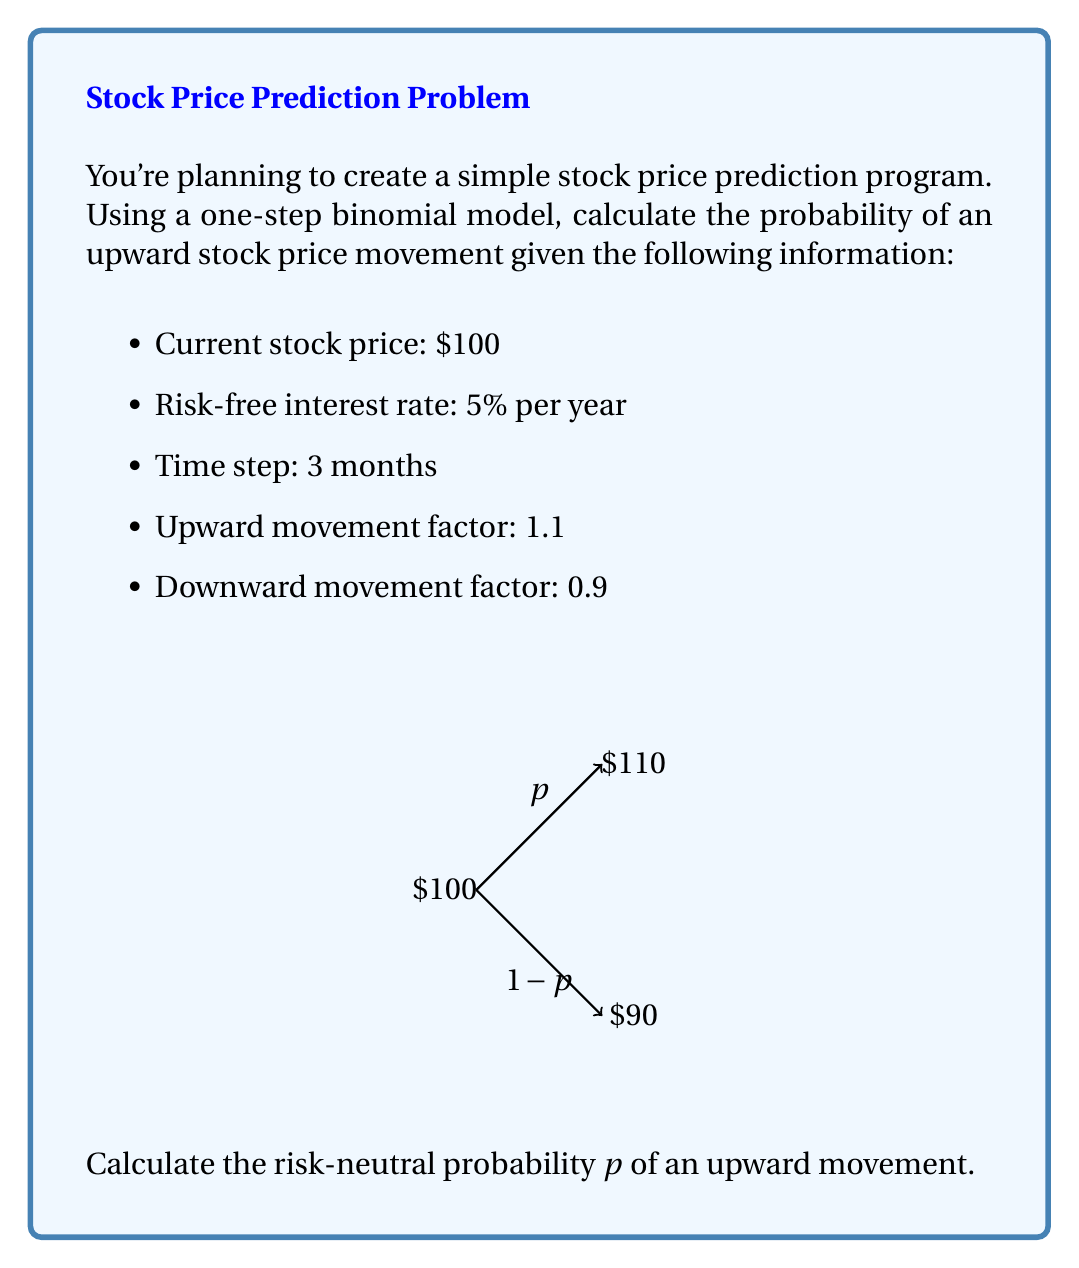Can you solve this math problem? To solve this problem using the binomial model, we'll follow these steps:

1) In a risk-neutral world, the expected return of the stock should equal the risk-free rate. We can express this as:

   $$p \cdot u + (1-p) \cdot d = e^{r\Delta t}$$

   where:
   $p$ is the probability of an upward movement
   $u$ is the upward movement factor
   $d$ is the downward movement factor
   $r$ is the risk-free rate
   $\Delta t$ is the time step in years

2) We're given:
   $u = 1.1$
   $d = 0.9$
   $r = 5\% = 0.05$
   $\Delta t = 3 \text{ months} = 0.25 \text{ years}$

3) Let's substitute these values into our equation:

   $$p \cdot 1.1 + (1-p) \cdot 0.9 = e^{0.05 \cdot 0.25}$$

4) First, let's calculate the right side:

   $$e^{0.05 \cdot 0.25} = e^{0.0125} \approx 1.012578$$

5) Now our equation looks like:

   $$p \cdot 1.1 + (1-p) \cdot 0.9 = 1.012578$$

6) Expand the left side:

   $$1.1p + 0.9 - 0.9p = 1.012578$$

7) Simplify:

   $$0.2p + 0.9 = 1.012578$$

8) Subtract 0.9 from both sides:

   $$0.2p = 0.112578$$

9) Divide both sides by 0.2:

   $$p = \frac{0.112578}{0.2} = 0.56289$$

Therefore, the risk-neutral probability of an upward movement is approximately 0.56289 or 56.289%.
Answer: $p \approx 0.56289$ 